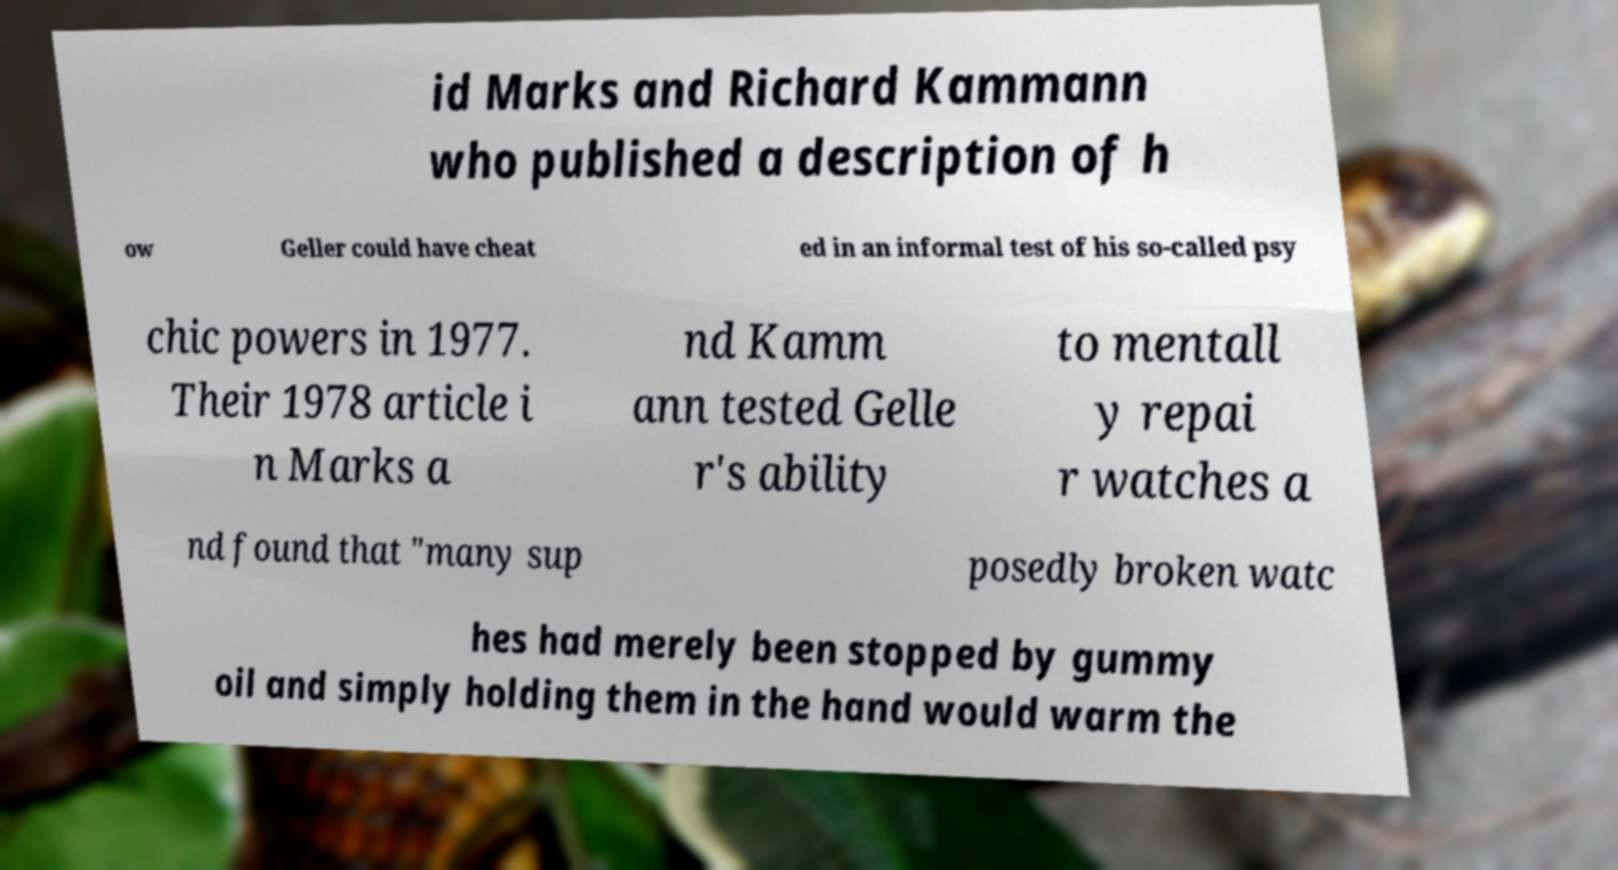Could you assist in decoding the text presented in this image and type it out clearly? id Marks and Richard Kammann who published a description of h ow Geller could have cheat ed in an informal test of his so-called psy chic powers in 1977. Their 1978 article i n Marks a nd Kamm ann tested Gelle r's ability to mentall y repai r watches a nd found that "many sup posedly broken watc hes had merely been stopped by gummy oil and simply holding them in the hand would warm the 